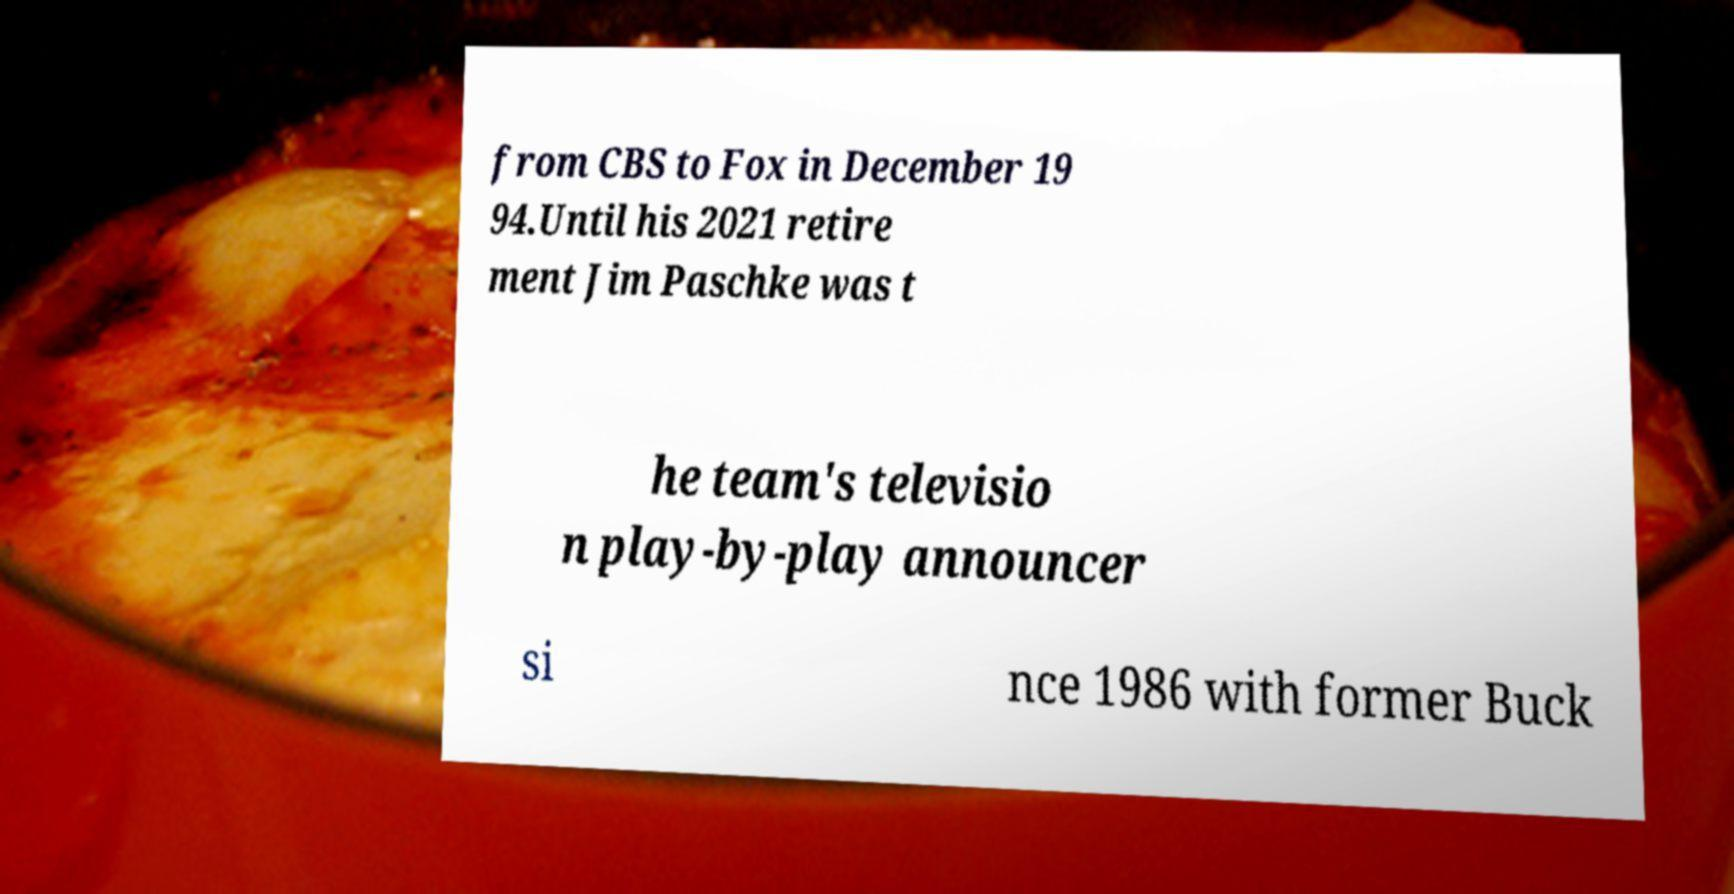What messages or text are displayed in this image? I need them in a readable, typed format. from CBS to Fox in December 19 94.Until his 2021 retire ment Jim Paschke was t he team's televisio n play-by-play announcer si nce 1986 with former Buck 